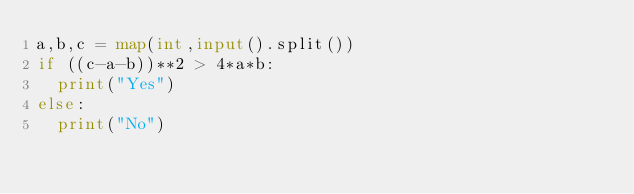<code> <loc_0><loc_0><loc_500><loc_500><_Python_>a,b,c = map(int,input().split())
if ((c-a-b))**2 > 4*a*b:
  print("Yes")
else:
  print("No")
</code> 